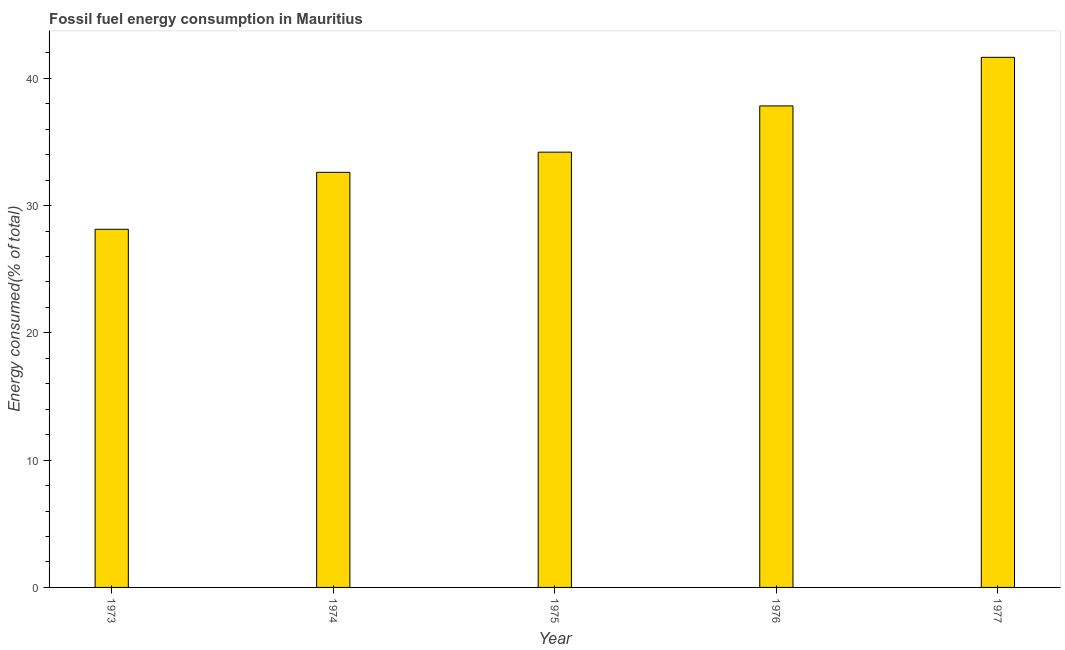Does the graph contain any zero values?
Offer a terse response. No. Does the graph contain grids?
Offer a very short reply. No. What is the title of the graph?
Your response must be concise. Fossil fuel energy consumption in Mauritius. What is the label or title of the X-axis?
Provide a succinct answer. Year. What is the label or title of the Y-axis?
Provide a short and direct response. Energy consumed(% of total). What is the fossil fuel energy consumption in 1976?
Ensure brevity in your answer.  37.84. Across all years, what is the maximum fossil fuel energy consumption?
Offer a terse response. 41.65. Across all years, what is the minimum fossil fuel energy consumption?
Keep it short and to the point. 28.14. In which year was the fossil fuel energy consumption minimum?
Your answer should be compact. 1973. What is the sum of the fossil fuel energy consumption?
Make the answer very short. 174.45. What is the difference between the fossil fuel energy consumption in 1975 and 1977?
Keep it short and to the point. -7.45. What is the average fossil fuel energy consumption per year?
Offer a very short reply. 34.89. What is the median fossil fuel energy consumption?
Provide a short and direct response. 34.2. Do a majority of the years between 1977 and 1976 (inclusive) have fossil fuel energy consumption greater than 24 %?
Make the answer very short. No. What is the ratio of the fossil fuel energy consumption in 1975 to that in 1977?
Give a very brief answer. 0.82. Is the difference between the fossil fuel energy consumption in 1976 and 1977 greater than the difference between any two years?
Offer a terse response. No. What is the difference between the highest and the second highest fossil fuel energy consumption?
Your answer should be very brief. 3.82. What is the difference between the highest and the lowest fossil fuel energy consumption?
Your answer should be very brief. 13.51. In how many years, is the fossil fuel energy consumption greater than the average fossil fuel energy consumption taken over all years?
Your answer should be compact. 2. How many bars are there?
Your answer should be very brief. 5. Are all the bars in the graph horizontal?
Give a very brief answer. No. What is the difference between two consecutive major ticks on the Y-axis?
Provide a short and direct response. 10. Are the values on the major ticks of Y-axis written in scientific E-notation?
Your answer should be compact. No. What is the Energy consumed(% of total) of 1973?
Provide a succinct answer. 28.14. What is the Energy consumed(% of total) of 1974?
Your answer should be very brief. 32.62. What is the Energy consumed(% of total) of 1975?
Your response must be concise. 34.2. What is the Energy consumed(% of total) in 1976?
Your answer should be compact. 37.84. What is the Energy consumed(% of total) in 1977?
Make the answer very short. 41.65. What is the difference between the Energy consumed(% of total) in 1973 and 1974?
Offer a very short reply. -4.48. What is the difference between the Energy consumed(% of total) in 1973 and 1975?
Give a very brief answer. -6.06. What is the difference between the Energy consumed(% of total) in 1973 and 1976?
Give a very brief answer. -9.69. What is the difference between the Energy consumed(% of total) in 1973 and 1977?
Your response must be concise. -13.51. What is the difference between the Energy consumed(% of total) in 1974 and 1975?
Provide a short and direct response. -1.59. What is the difference between the Energy consumed(% of total) in 1974 and 1976?
Keep it short and to the point. -5.22. What is the difference between the Energy consumed(% of total) in 1974 and 1977?
Offer a very short reply. -9.04. What is the difference between the Energy consumed(% of total) in 1975 and 1976?
Offer a very short reply. -3.63. What is the difference between the Energy consumed(% of total) in 1975 and 1977?
Your answer should be very brief. -7.45. What is the difference between the Energy consumed(% of total) in 1976 and 1977?
Make the answer very short. -3.82. What is the ratio of the Energy consumed(% of total) in 1973 to that in 1974?
Your answer should be compact. 0.86. What is the ratio of the Energy consumed(% of total) in 1973 to that in 1975?
Provide a short and direct response. 0.82. What is the ratio of the Energy consumed(% of total) in 1973 to that in 1976?
Ensure brevity in your answer.  0.74. What is the ratio of the Energy consumed(% of total) in 1973 to that in 1977?
Ensure brevity in your answer.  0.68. What is the ratio of the Energy consumed(% of total) in 1974 to that in 1975?
Your answer should be very brief. 0.95. What is the ratio of the Energy consumed(% of total) in 1974 to that in 1976?
Ensure brevity in your answer.  0.86. What is the ratio of the Energy consumed(% of total) in 1974 to that in 1977?
Offer a very short reply. 0.78. What is the ratio of the Energy consumed(% of total) in 1975 to that in 1976?
Provide a short and direct response. 0.9. What is the ratio of the Energy consumed(% of total) in 1975 to that in 1977?
Provide a short and direct response. 0.82. What is the ratio of the Energy consumed(% of total) in 1976 to that in 1977?
Your answer should be very brief. 0.91. 